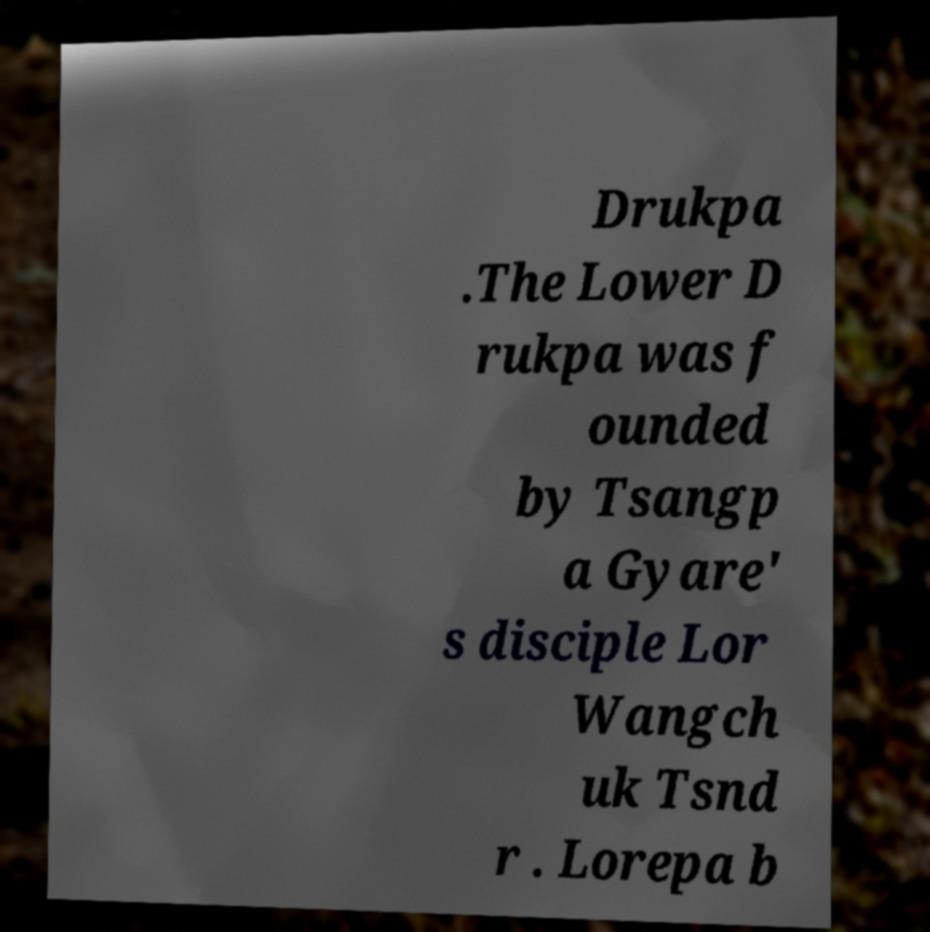For documentation purposes, I need the text within this image transcribed. Could you provide that? Drukpa .The Lower D rukpa was f ounded by Tsangp a Gyare' s disciple Lor Wangch uk Tsnd r . Lorepa b 